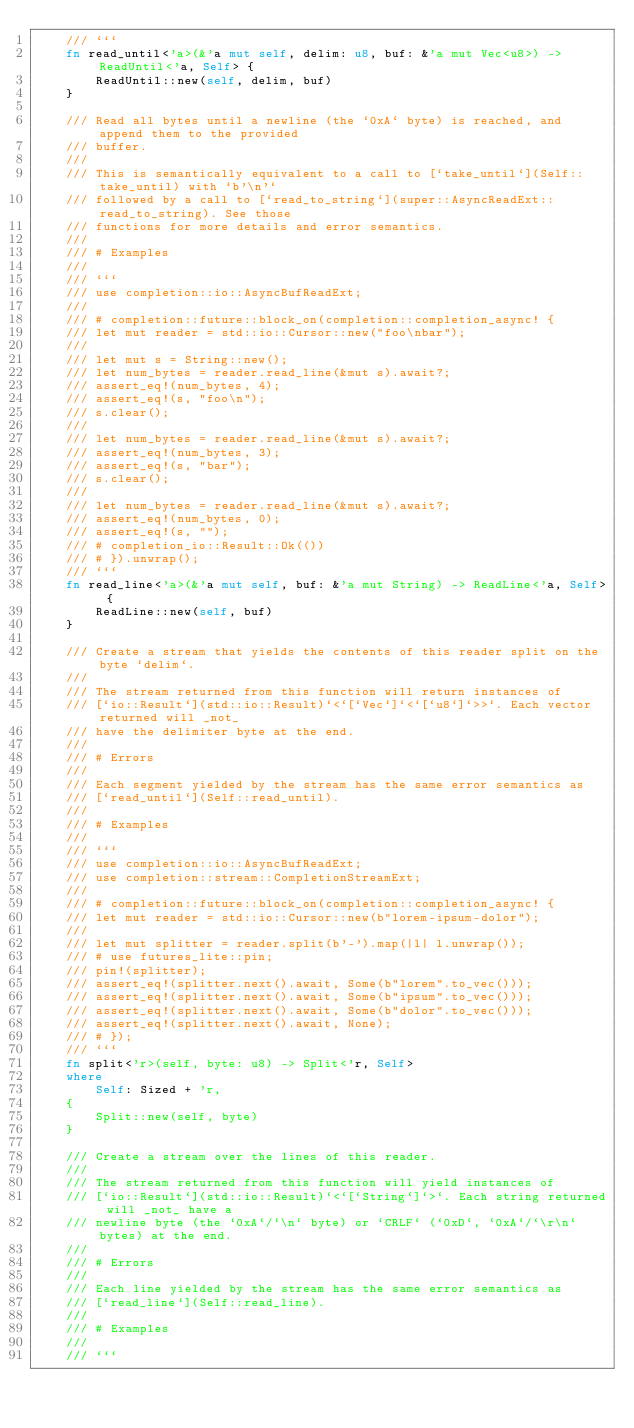<code> <loc_0><loc_0><loc_500><loc_500><_Rust_>    /// ```
    fn read_until<'a>(&'a mut self, delim: u8, buf: &'a mut Vec<u8>) -> ReadUntil<'a, Self> {
        ReadUntil::new(self, delim, buf)
    }

    /// Read all bytes until a newline (the `0xA` byte) is reached, and append them to the provided
    /// buffer.
    ///
    /// This is semantically equivalent to a call to [`take_until`](Self::take_until) with `b'\n'`
    /// followed by a call to [`read_to_string`](super::AsyncReadExt::read_to_string). See those
    /// functions for more details and error semantics.
    ///
    /// # Examples
    ///
    /// ```
    /// use completion::io::AsyncBufReadExt;
    ///
    /// # completion::future::block_on(completion::completion_async! {
    /// let mut reader = std::io::Cursor::new("foo\nbar");
    ///
    /// let mut s = String::new();
    /// let num_bytes = reader.read_line(&mut s).await?;
    /// assert_eq!(num_bytes, 4);
    /// assert_eq!(s, "foo\n");
    /// s.clear();
    ///
    /// let num_bytes = reader.read_line(&mut s).await?;
    /// assert_eq!(num_bytes, 3);
    /// assert_eq!(s, "bar");
    /// s.clear();
    ///
    /// let num_bytes = reader.read_line(&mut s).await?;
    /// assert_eq!(num_bytes, 0);
    /// assert_eq!(s, "");
    /// # completion_io::Result::Ok(())
    /// # }).unwrap();
    /// ```
    fn read_line<'a>(&'a mut self, buf: &'a mut String) -> ReadLine<'a, Self> {
        ReadLine::new(self, buf)
    }

    /// Create a stream that yields the contents of this reader split on the byte `delim`.
    ///
    /// The stream returned from this function will return instances of
    /// [`io::Result`](std::io::Result)`<`[`Vec`]`<`[`u8`]`>>`. Each vector returned will _not_
    /// have the delimiter byte at the end.
    ///
    /// # Errors
    ///
    /// Each segment yielded by the stream has the same error semantics as
    /// [`read_until`](Self::read_until).
    ///
    /// # Examples
    ///
    /// ```
    /// use completion::io::AsyncBufReadExt;
    /// use completion::stream::CompletionStreamExt;
    ///
    /// # completion::future::block_on(completion::completion_async! {
    /// let mut reader = std::io::Cursor::new(b"lorem-ipsum-dolor");
    ///
    /// let mut splitter = reader.split(b'-').map(|l| l.unwrap());
    /// # use futures_lite::pin;
    /// pin!(splitter);
    /// assert_eq!(splitter.next().await, Some(b"lorem".to_vec()));
    /// assert_eq!(splitter.next().await, Some(b"ipsum".to_vec()));
    /// assert_eq!(splitter.next().await, Some(b"dolor".to_vec()));
    /// assert_eq!(splitter.next().await, None);
    /// # });
    /// ```
    fn split<'r>(self, byte: u8) -> Split<'r, Self>
    where
        Self: Sized + 'r,
    {
        Split::new(self, byte)
    }

    /// Create a stream over the lines of this reader.
    ///
    /// The stream returned from this function will yield instances of
    /// [`io::Result`](std::io::Result)`<`[`String`]`>`. Each string returned will _not_ have a
    /// newline byte (the `0xA`/`\n` byte) or `CRLF` (`0xD`, `0xA`/`\r\n` bytes) at the end.
    ///
    /// # Errors
    ///
    /// Each line yielded by the stream has the same error semantics as
    /// [`read_line`](Self::read_line).
    ///
    /// # Examples
    ///
    /// ```</code> 